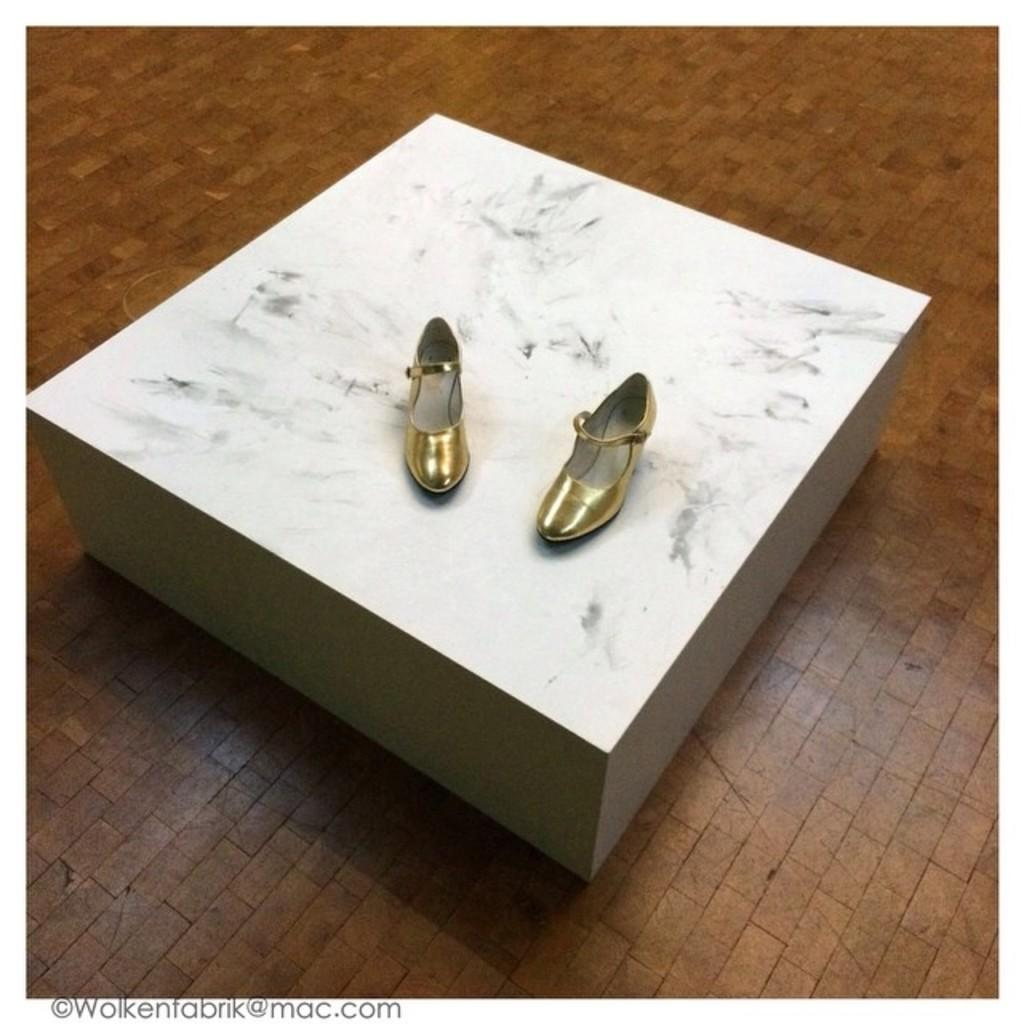What color are the shoes in the image? The shoes in the image are gold in color. How are the shoes positioned in the image? The shoes are on a board in the image. Is there any additional mark or feature on the image? Yes, there is a watermark on the image. Can you tell me the opinion of the robin about the gold color shoes in the image? There is no robin present in the image, so it is not possible to determine its opinion about the gold color shoes. 